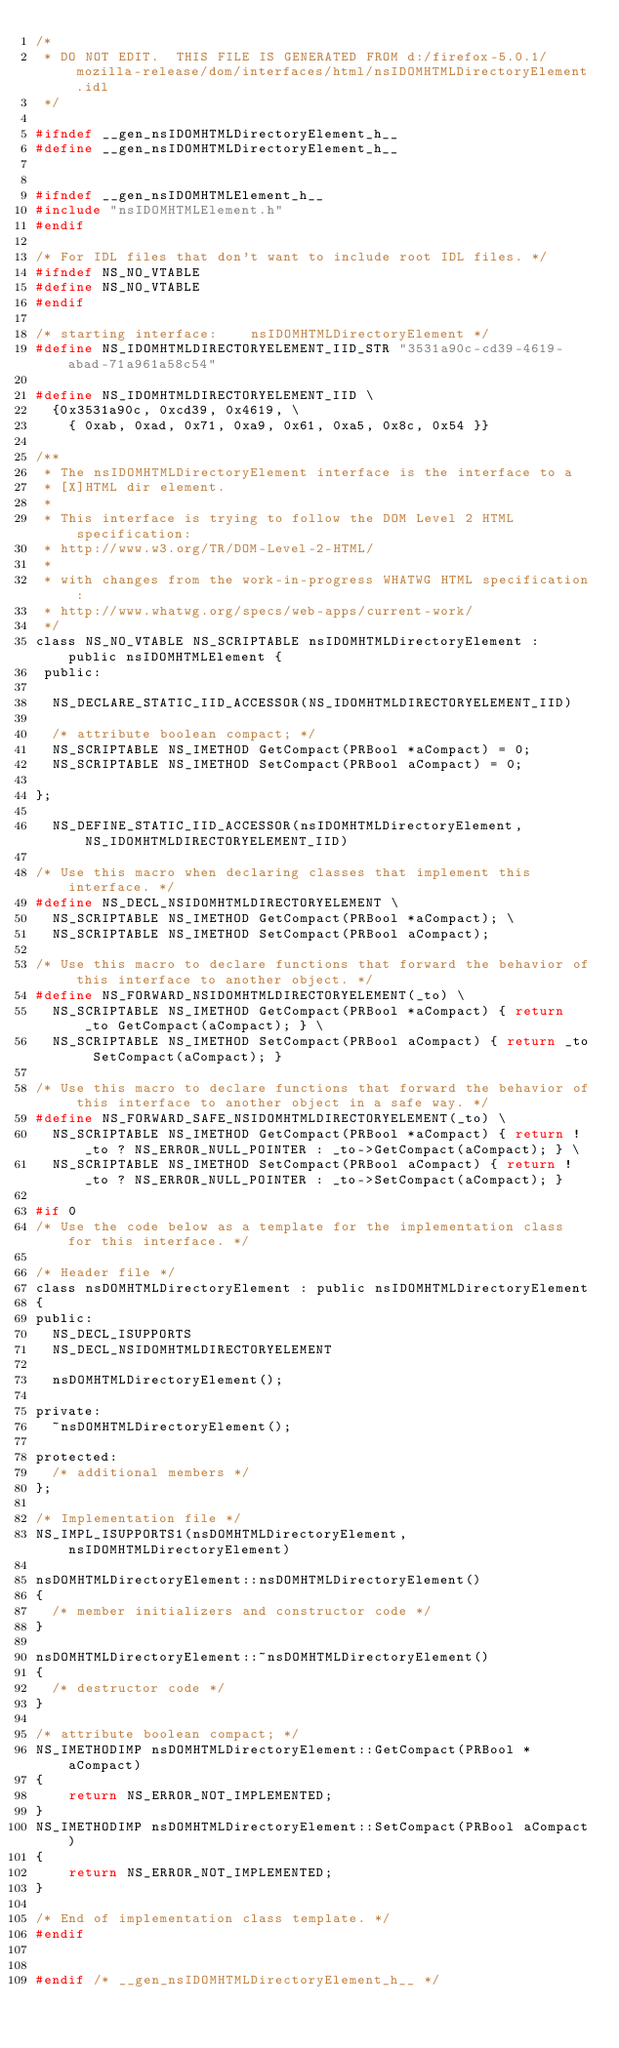<code> <loc_0><loc_0><loc_500><loc_500><_C_>/*
 * DO NOT EDIT.  THIS FILE IS GENERATED FROM d:/firefox-5.0.1/mozilla-release/dom/interfaces/html/nsIDOMHTMLDirectoryElement.idl
 */

#ifndef __gen_nsIDOMHTMLDirectoryElement_h__
#define __gen_nsIDOMHTMLDirectoryElement_h__


#ifndef __gen_nsIDOMHTMLElement_h__
#include "nsIDOMHTMLElement.h"
#endif

/* For IDL files that don't want to include root IDL files. */
#ifndef NS_NO_VTABLE
#define NS_NO_VTABLE
#endif

/* starting interface:    nsIDOMHTMLDirectoryElement */
#define NS_IDOMHTMLDIRECTORYELEMENT_IID_STR "3531a90c-cd39-4619-abad-71a961a58c54"

#define NS_IDOMHTMLDIRECTORYELEMENT_IID \
  {0x3531a90c, 0xcd39, 0x4619, \
    { 0xab, 0xad, 0x71, 0xa9, 0x61, 0xa5, 0x8c, 0x54 }}

/**
 * The nsIDOMHTMLDirectoryElement interface is the interface to a
 * [X]HTML dir element.
 *
 * This interface is trying to follow the DOM Level 2 HTML specification:
 * http://www.w3.org/TR/DOM-Level-2-HTML/
 *
 * with changes from the work-in-progress WHATWG HTML specification:
 * http://www.whatwg.org/specs/web-apps/current-work/
 */
class NS_NO_VTABLE NS_SCRIPTABLE nsIDOMHTMLDirectoryElement : public nsIDOMHTMLElement {
 public: 

  NS_DECLARE_STATIC_IID_ACCESSOR(NS_IDOMHTMLDIRECTORYELEMENT_IID)

  /* attribute boolean compact; */
  NS_SCRIPTABLE NS_IMETHOD GetCompact(PRBool *aCompact) = 0;
  NS_SCRIPTABLE NS_IMETHOD SetCompact(PRBool aCompact) = 0;

};

  NS_DEFINE_STATIC_IID_ACCESSOR(nsIDOMHTMLDirectoryElement, NS_IDOMHTMLDIRECTORYELEMENT_IID)

/* Use this macro when declaring classes that implement this interface. */
#define NS_DECL_NSIDOMHTMLDIRECTORYELEMENT \
  NS_SCRIPTABLE NS_IMETHOD GetCompact(PRBool *aCompact); \
  NS_SCRIPTABLE NS_IMETHOD SetCompact(PRBool aCompact); 

/* Use this macro to declare functions that forward the behavior of this interface to another object. */
#define NS_FORWARD_NSIDOMHTMLDIRECTORYELEMENT(_to) \
  NS_SCRIPTABLE NS_IMETHOD GetCompact(PRBool *aCompact) { return _to GetCompact(aCompact); } \
  NS_SCRIPTABLE NS_IMETHOD SetCompact(PRBool aCompact) { return _to SetCompact(aCompact); } 

/* Use this macro to declare functions that forward the behavior of this interface to another object in a safe way. */
#define NS_FORWARD_SAFE_NSIDOMHTMLDIRECTORYELEMENT(_to) \
  NS_SCRIPTABLE NS_IMETHOD GetCompact(PRBool *aCompact) { return !_to ? NS_ERROR_NULL_POINTER : _to->GetCompact(aCompact); } \
  NS_SCRIPTABLE NS_IMETHOD SetCompact(PRBool aCompact) { return !_to ? NS_ERROR_NULL_POINTER : _to->SetCompact(aCompact); } 

#if 0
/* Use the code below as a template for the implementation class for this interface. */

/* Header file */
class nsDOMHTMLDirectoryElement : public nsIDOMHTMLDirectoryElement
{
public:
  NS_DECL_ISUPPORTS
  NS_DECL_NSIDOMHTMLDIRECTORYELEMENT

  nsDOMHTMLDirectoryElement();

private:
  ~nsDOMHTMLDirectoryElement();

protected:
  /* additional members */
};

/* Implementation file */
NS_IMPL_ISUPPORTS1(nsDOMHTMLDirectoryElement, nsIDOMHTMLDirectoryElement)

nsDOMHTMLDirectoryElement::nsDOMHTMLDirectoryElement()
{
  /* member initializers and constructor code */
}

nsDOMHTMLDirectoryElement::~nsDOMHTMLDirectoryElement()
{
  /* destructor code */
}

/* attribute boolean compact; */
NS_IMETHODIMP nsDOMHTMLDirectoryElement::GetCompact(PRBool *aCompact)
{
    return NS_ERROR_NOT_IMPLEMENTED;
}
NS_IMETHODIMP nsDOMHTMLDirectoryElement::SetCompact(PRBool aCompact)
{
    return NS_ERROR_NOT_IMPLEMENTED;
}

/* End of implementation class template. */
#endif


#endif /* __gen_nsIDOMHTMLDirectoryElement_h__ */
</code> 